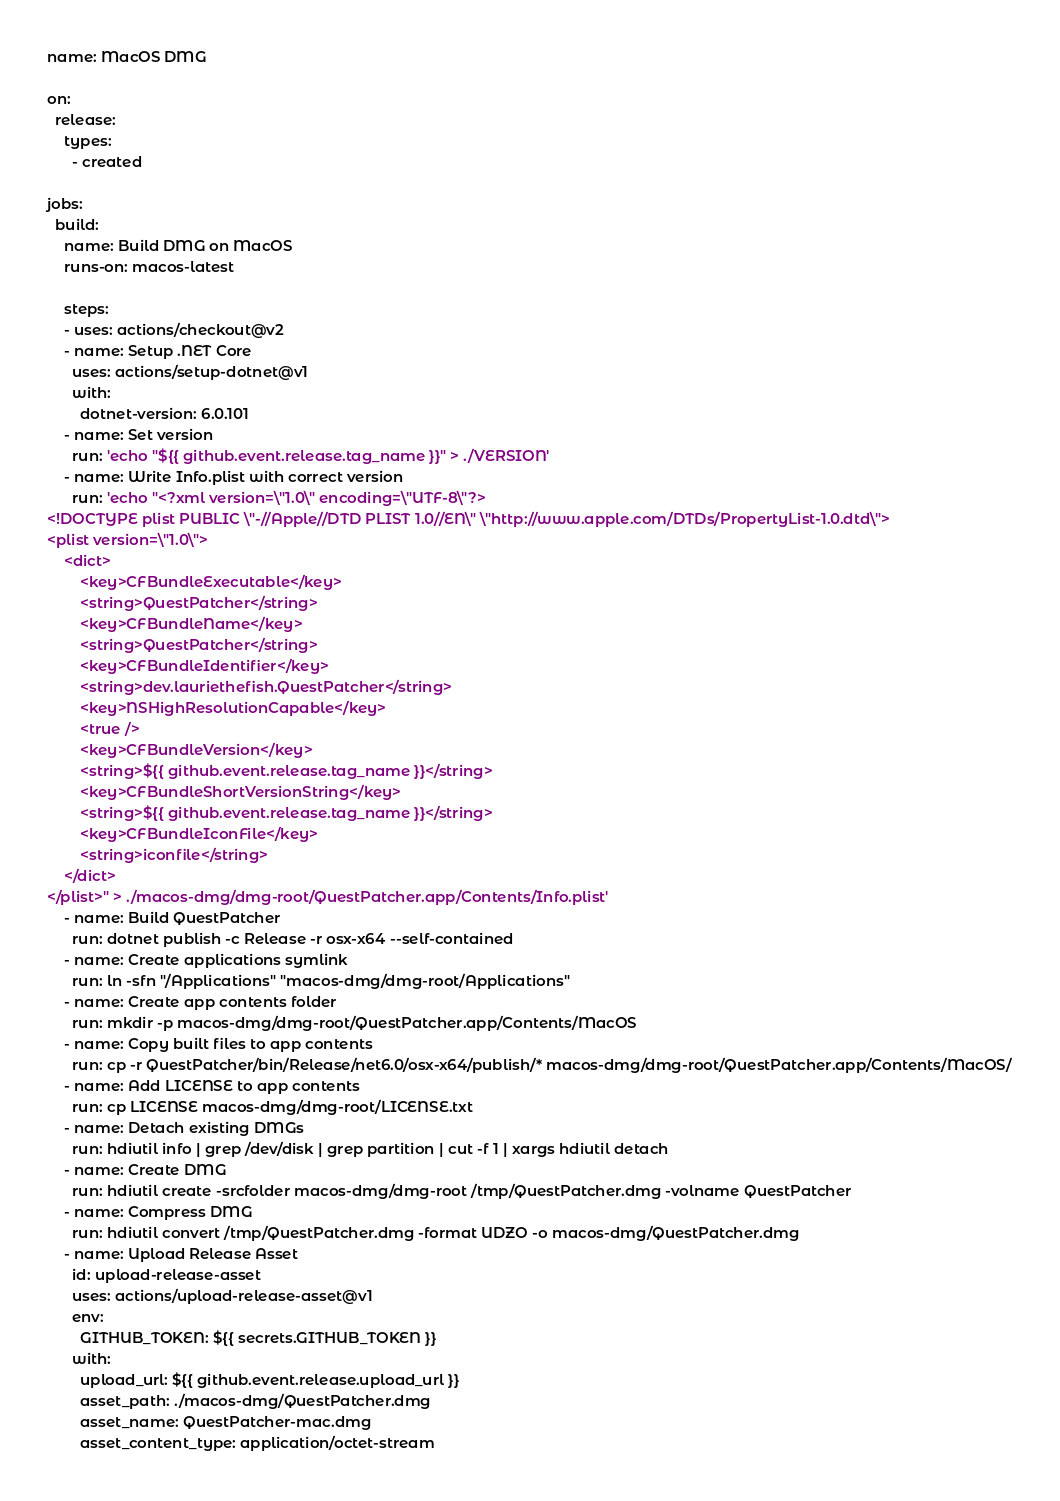Convert code to text. <code><loc_0><loc_0><loc_500><loc_500><_YAML_>name: MacOS DMG

on:
  release:
    types:
      - created

jobs:
  build:
    name: Build DMG on MacOS
    runs-on: macos-latest

    steps:
    - uses: actions/checkout@v2
    - name: Setup .NET Core
      uses: actions/setup-dotnet@v1
      with:
        dotnet-version: 6.0.101
    - name: Set version
      run: 'echo "${{ github.event.release.tag_name }}" > ./VERSION'
    - name: Write Info.plist with correct version
      run: 'echo "<?xml version=\"1.0\" encoding=\"UTF-8\"?>
<!DOCTYPE plist PUBLIC \"-//Apple//DTD PLIST 1.0//EN\" \"http://www.apple.com/DTDs/PropertyList-1.0.dtd\">
<plist version=\"1.0\">
    <dict>
        <key>CFBundleExecutable</key>
        <string>QuestPatcher</string>
        <key>CFBundleName</key>
        <string>QuestPatcher</string>
        <key>CFBundleIdentifier</key>
        <string>dev.lauriethefish.QuestPatcher</string>
        <key>NSHighResolutionCapable</key>
        <true />
        <key>CFBundleVersion</key>
        <string>${{ github.event.release.tag_name }}</string>
        <key>CFBundleShortVersionString</key>
        <string>${{ github.event.release.tag_name }}</string>
        <key>CFBundleIconFile</key>
        <string>iconfile</string>
    </dict>
</plist>" > ./macos-dmg/dmg-root/QuestPatcher.app/Contents/Info.plist'
    - name: Build QuestPatcher
      run: dotnet publish -c Release -r osx-x64 --self-contained
    - name: Create applications symlink
      run: ln -sfn "/Applications" "macos-dmg/dmg-root/Applications"
    - name: Create app contents folder
      run: mkdir -p macos-dmg/dmg-root/QuestPatcher.app/Contents/MacOS
    - name: Copy built files to app contents
      run: cp -r QuestPatcher/bin/Release/net6.0/osx-x64/publish/* macos-dmg/dmg-root/QuestPatcher.app/Contents/MacOS/
    - name: Add LICENSE to app contents
      run: cp LICENSE macos-dmg/dmg-root/LICENSE.txt
    - name: Detach existing DMGs
      run: hdiutil info | grep /dev/disk | grep partition | cut -f 1 | xargs hdiutil detach
    - name: Create DMG
      run: hdiutil create -srcfolder macos-dmg/dmg-root /tmp/QuestPatcher.dmg -volname QuestPatcher
    - name: Compress DMG
      run: hdiutil convert /tmp/QuestPatcher.dmg -format UDZO -o macos-dmg/QuestPatcher.dmg
    - name: Upload Release Asset
      id: upload-release-asset 
      uses: actions/upload-release-asset@v1
      env:
        GITHUB_TOKEN: ${{ secrets.GITHUB_TOKEN }}
      with:
        upload_url: ${{ github.event.release.upload_url }}
        asset_path: ./macos-dmg/QuestPatcher.dmg
        asset_name: QuestPatcher-mac.dmg
        asset_content_type: application/octet-stream</code> 